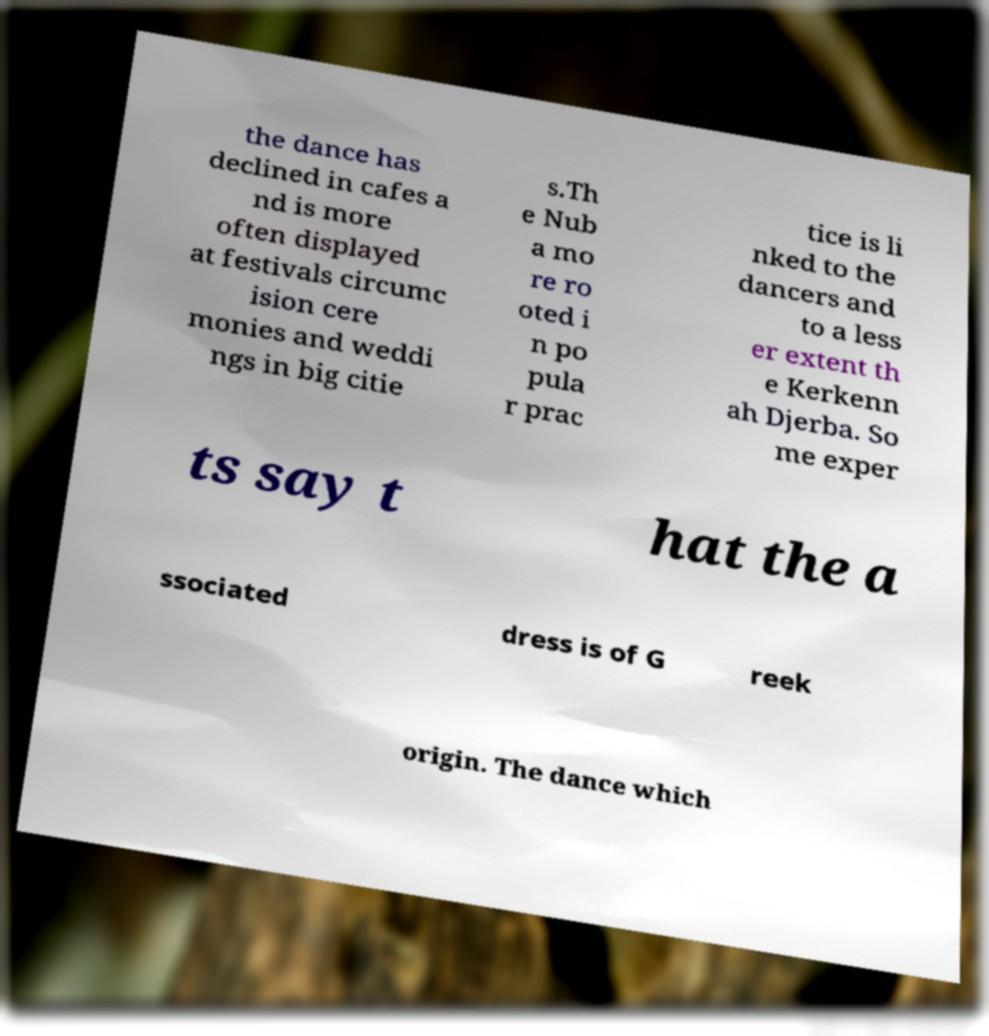Please identify and transcribe the text found in this image. the dance has declined in cafes a nd is more often displayed at festivals circumc ision cere monies and weddi ngs in big citie s.Th e Nub a mo re ro oted i n po pula r prac tice is li nked to the dancers and to a less er extent th e Kerkenn ah Djerba. So me exper ts say t hat the a ssociated dress is of G reek origin. The dance which 